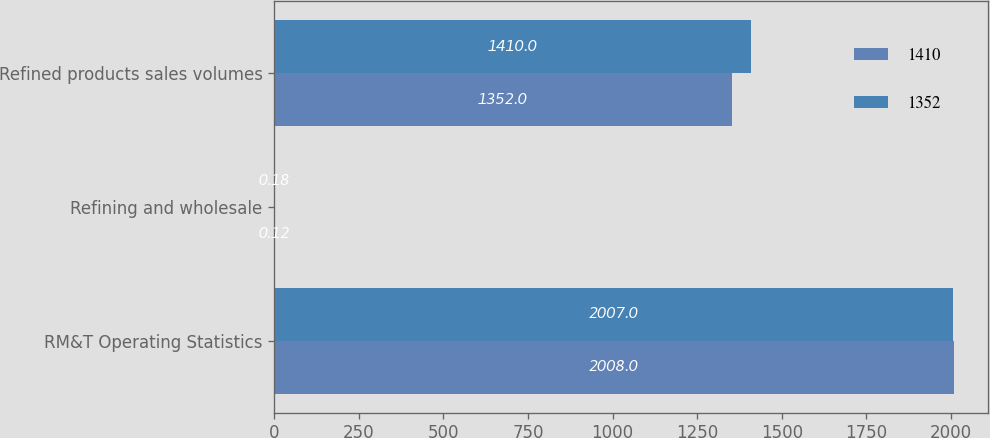<chart> <loc_0><loc_0><loc_500><loc_500><stacked_bar_chart><ecel><fcel>RM&T Operating Statistics<fcel>Refining and wholesale<fcel>Refined products sales volumes<nl><fcel>1410<fcel>2008<fcel>0.12<fcel>1352<nl><fcel>1352<fcel>2007<fcel>0.18<fcel>1410<nl></chart> 